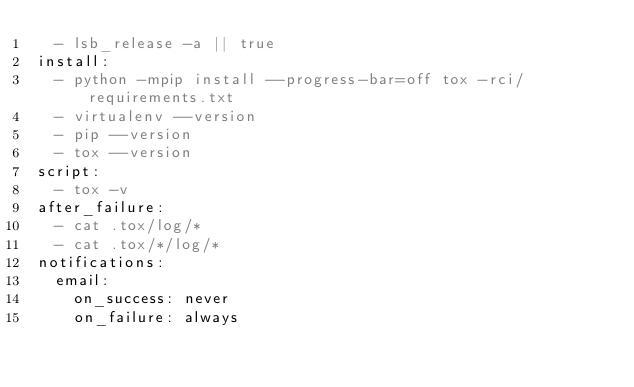<code> <loc_0><loc_0><loc_500><loc_500><_YAML_>  - lsb_release -a || true
install:
  - python -mpip install --progress-bar=off tox -rci/requirements.txt
  - virtualenv --version
  - pip --version
  - tox --version
script:
  - tox -v
after_failure:
  - cat .tox/log/*
  - cat .tox/*/log/*
notifications:
  email:
    on_success: never
    on_failure: always
</code> 